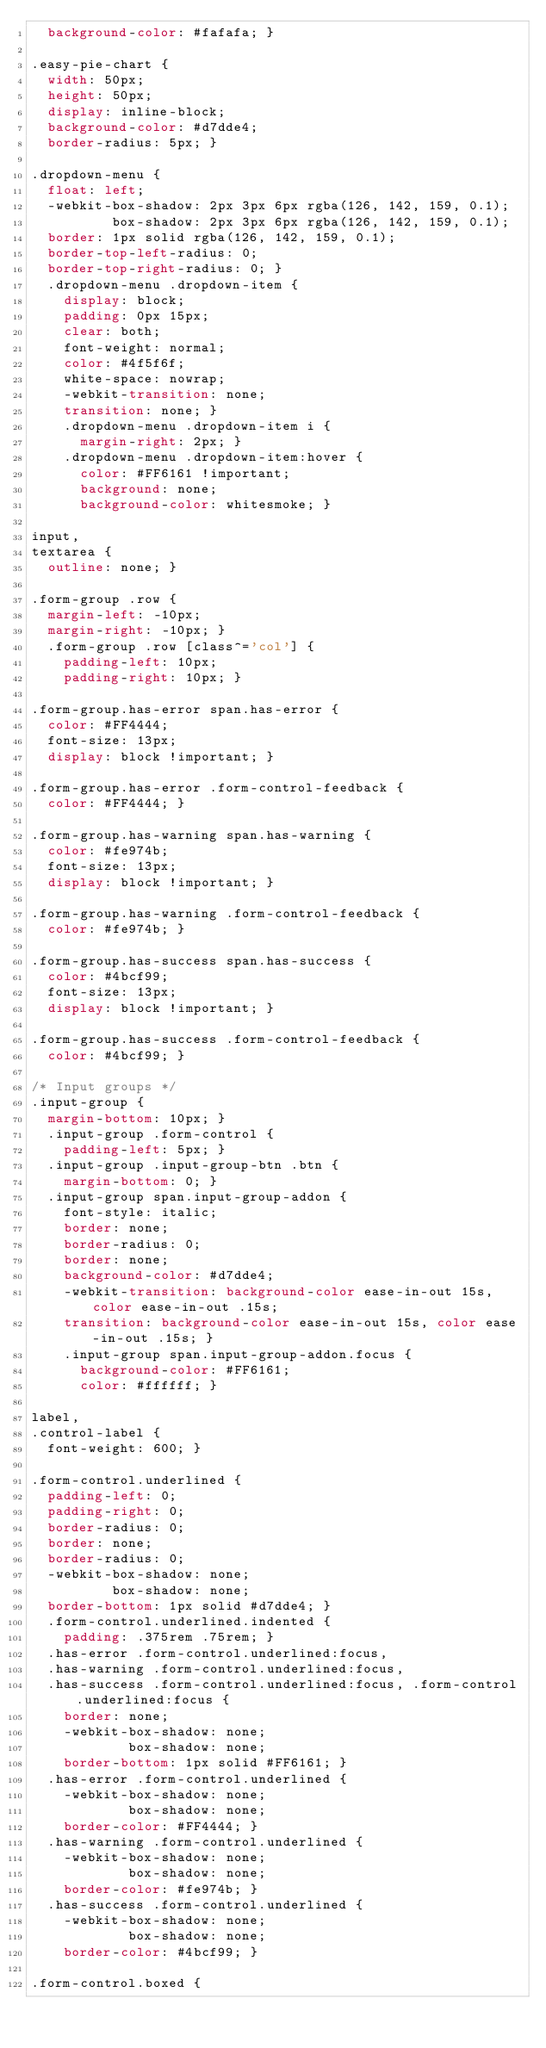<code> <loc_0><loc_0><loc_500><loc_500><_CSS_>  background-color: #fafafa; }

.easy-pie-chart {
  width: 50px;
  height: 50px;
  display: inline-block;
  background-color: #d7dde4;
  border-radius: 5px; }

.dropdown-menu {
  float: left;
  -webkit-box-shadow: 2px 3px 6px rgba(126, 142, 159, 0.1);
          box-shadow: 2px 3px 6px rgba(126, 142, 159, 0.1);
  border: 1px solid rgba(126, 142, 159, 0.1);
  border-top-left-radius: 0;
  border-top-right-radius: 0; }
  .dropdown-menu .dropdown-item {
    display: block;
    padding: 0px 15px;
    clear: both;
    font-weight: normal;
    color: #4f5f6f;
    white-space: nowrap;
    -webkit-transition: none;
    transition: none; }
    .dropdown-menu .dropdown-item i {
      margin-right: 2px; }
    .dropdown-menu .dropdown-item:hover {
      color: #FF6161 !important;
      background: none;
      background-color: whitesmoke; }

input,
textarea {
  outline: none; }

.form-group .row {
  margin-left: -10px;
  margin-right: -10px; }
  .form-group .row [class^='col'] {
    padding-left: 10px;
    padding-right: 10px; }

.form-group.has-error span.has-error {
  color: #FF4444;
  font-size: 13px;
  display: block !important; }

.form-group.has-error .form-control-feedback {
  color: #FF4444; }

.form-group.has-warning span.has-warning {
  color: #fe974b;
  font-size: 13px;
  display: block !important; }

.form-group.has-warning .form-control-feedback {
  color: #fe974b; }

.form-group.has-success span.has-success {
  color: #4bcf99;
  font-size: 13px;
  display: block !important; }

.form-group.has-success .form-control-feedback {
  color: #4bcf99; }

/* Input groups */
.input-group {
  margin-bottom: 10px; }
  .input-group .form-control {
    padding-left: 5px; }
  .input-group .input-group-btn .btn {
    margin-bottom: 0; }
  .input-group span.input-group-addon {
    font-style: italic;
    border: none;
    border-radius: 0;
    border: none;
    background-color: #d7dde4;
    -webkit-transition: background-color ease-in-out 15s, color ease-in-out .15s;
    transition: background-color ease-in-out 15s, color ease-in-out .15s; }
    .input-group span.input-group-addon.focus {
      background-color: #FF6161;
      color: #ffffff; }

label,
.control-label {
  font-weight: 600; }

.form-control.underlined {
  padding-left: 0;
  padding-right: 0;
  border-radius: 0;
  border: none;
  border-radius: 0;
  -webkit-box-shadow: none;
          box-shadow: none;
  border-bottom: 1px solid #d7dde4; }
  .form-control.underlined.indented {
    padding: .375rem .75rem; }
  .has-error .form-control.underlined:focus,
  .has-warning .form-control.underlined:focus,
  .has-success .form-control.underlined:focus, .form-control.underlined:focus {
    border: none;
    -webkit-box-shadow: none;
            box-shadow: none;
    border-bottom: 1px solid #FF6161; }
  .has-error .form-control.underlined {
    -webkit-box-shadow: none;
            box-shadow: none;
    border-color: #FF4444; }
  .has-warning .form-control.underlined {
    -webkit-box-shadow: none;
            box-shadow: none;
    border-color: #fe974b; }
  .has-success .form-control.underlined {
    -webkit-box-shadow: none;
            box-shadow: none;
    border-color: #4bcf99; }

.form-control.boxed {</code> 